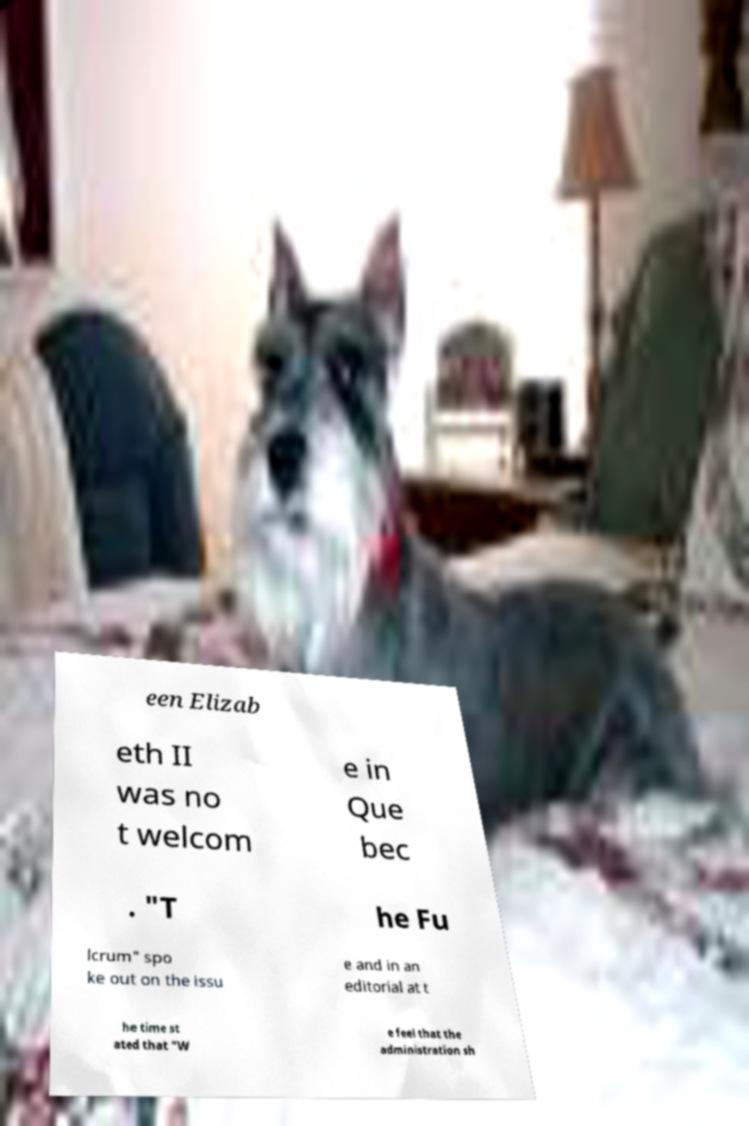Can you accurately transcribe the text from the provided image for me? een Elizab eth II was no t welcom e in Que bec . "T he Fu lcrum" spo ke out on the issu e and in an editorial at t he time st ated that "W e feel that the administration sh 